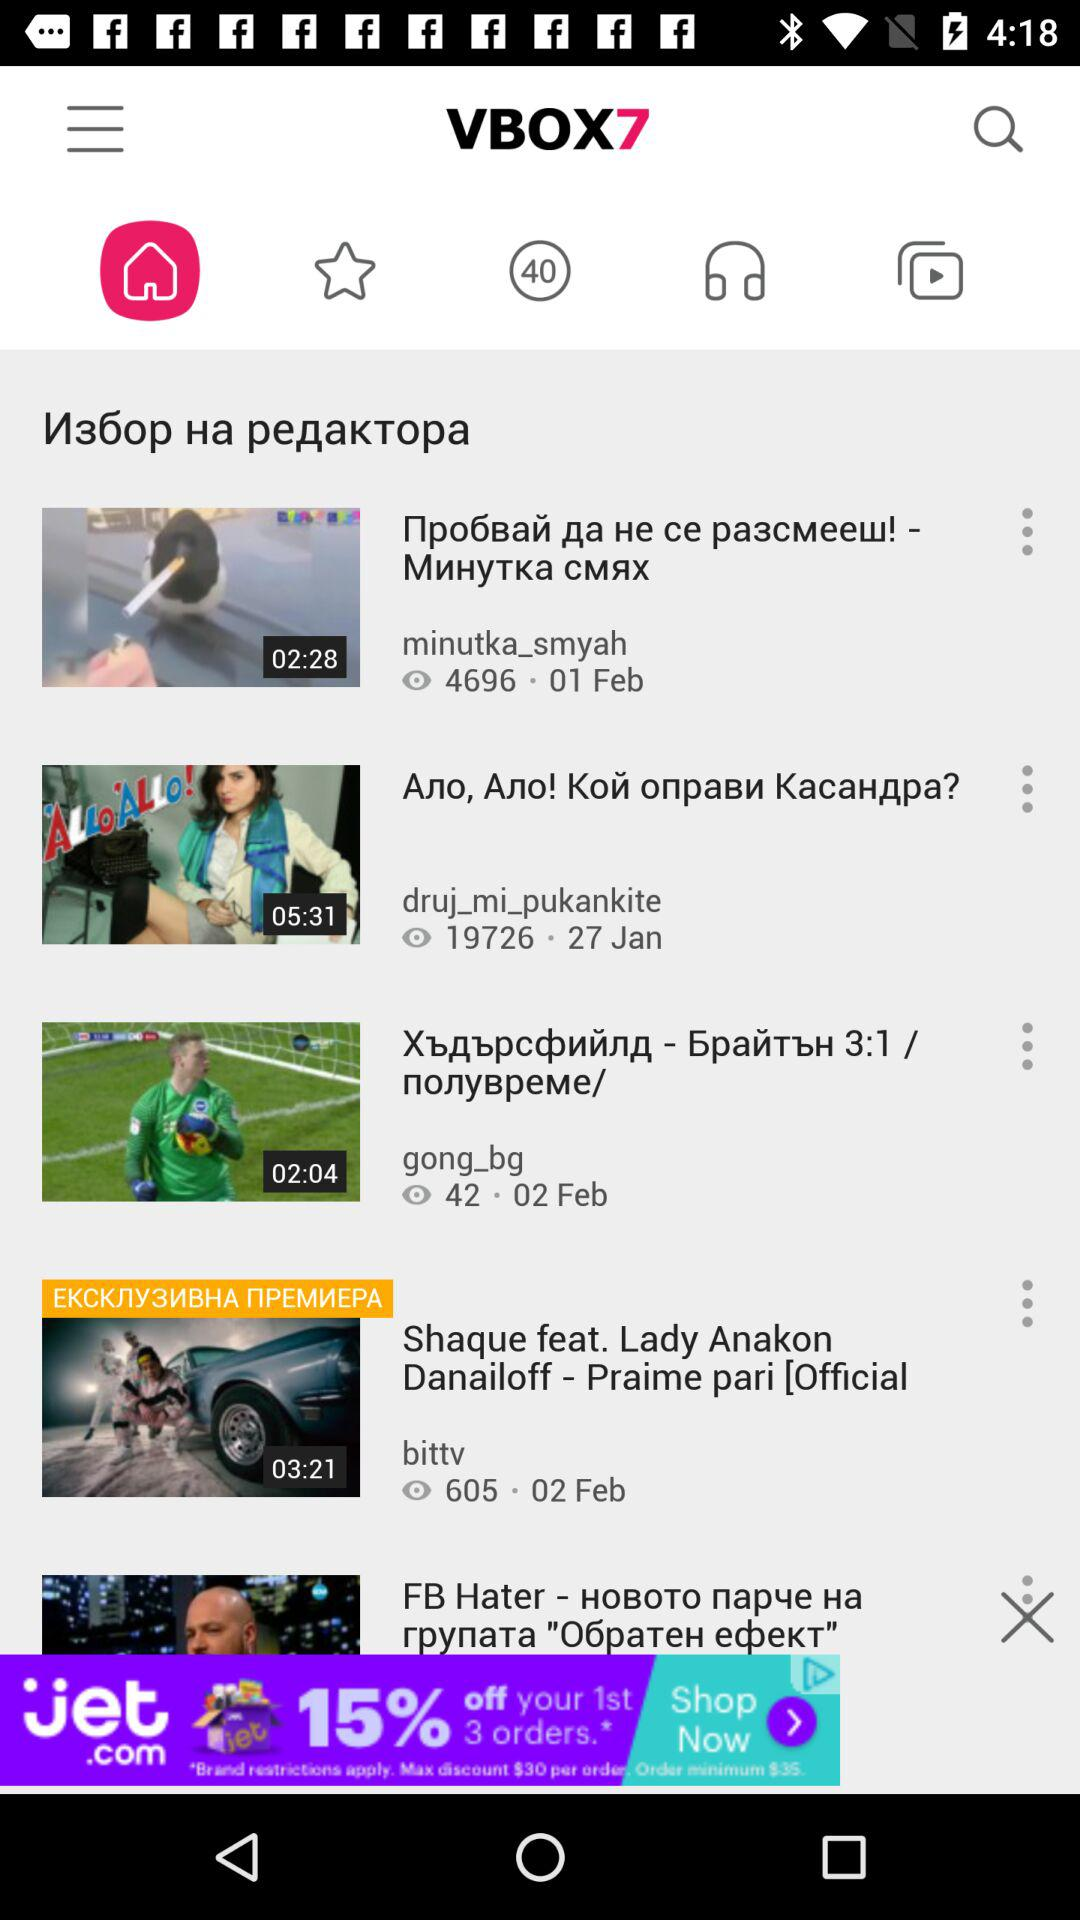How many videos have a duration of less than 3 minutes?
Answer the question using a single word or phrase. 2 